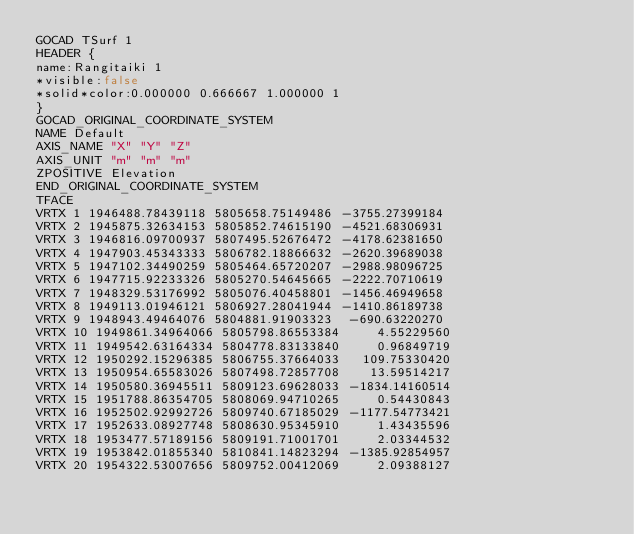Convert code to text. <code><loc_0><loc_0><loc_500><loc_500><_TypeScript_>GOCAD TSurf 1
HEADER {
name:Rangitaiki 1
*visible:false
*solid*color:0.000000 0.666667 1.000000 1
}
GOCAD_ORIGINAL_COORDINATE_SYSTEM
NAME Default
AXIS_NAME "X" "Y" "Z"
AXIS_UNIT "m" "m" "m"
ZPOSITIVE Elevation
END_ORIGINAL_COORDINATE_SYSTEM
TFACE
VRTX 1 1946488.78439118 5805658.75149486 -3755.27399184
VRTX 2 1945875.32634153 5805852.74615190 -4521.68306931
VRTX 3 1946816.09700937 5807495.52676472 -4178.62381650
VRTX 4 1947903.45343333 5806782.18866632 -2620.39689038
VRTX 5 1947102.34490259 5805464.65720207 -2988.98096725
VRTX 6 1947715.92233326 5805270.54645665 -2222.70710619
VRTX 7 1948329.53176992 5805076.40458801 -1456.46949658
VRTX 8 1949113.01946121 5806927.28041944 -1410.86189738
VRTX 9 1948943.49464076 5804881.91903323  -690.63220270
VRTX 10 1949861.34964066 5805798.86553384     4.55229560
VRTX 11 1949542.63164334 5804778.83133840     0.96849719
VRTX 12 1950292.15296385 5806755.37664033   109.75330420
VRTX 13 1950954.65583026 5807498.72857708    13.59514217
VRTX 14 1950580.36945511 5809123.69628033 -1834.14160514
VRTX 15 1951788.86354705 5808069.94710265     0.54430843
VRTX 16 1952502.92992726 5809740.67185029 -1177.54773421
VRTX 17 1952633.08927748 5808630.95345910     1.43435596
VRTX 18 1953477.57189156 5809191.71001701     2.03344532
VRTX 19 1953842.01855340 5810841.14823294 -1385.92854957
VRTX 20 1954322.53007656 5809752.00412069     2.09388127</code> 